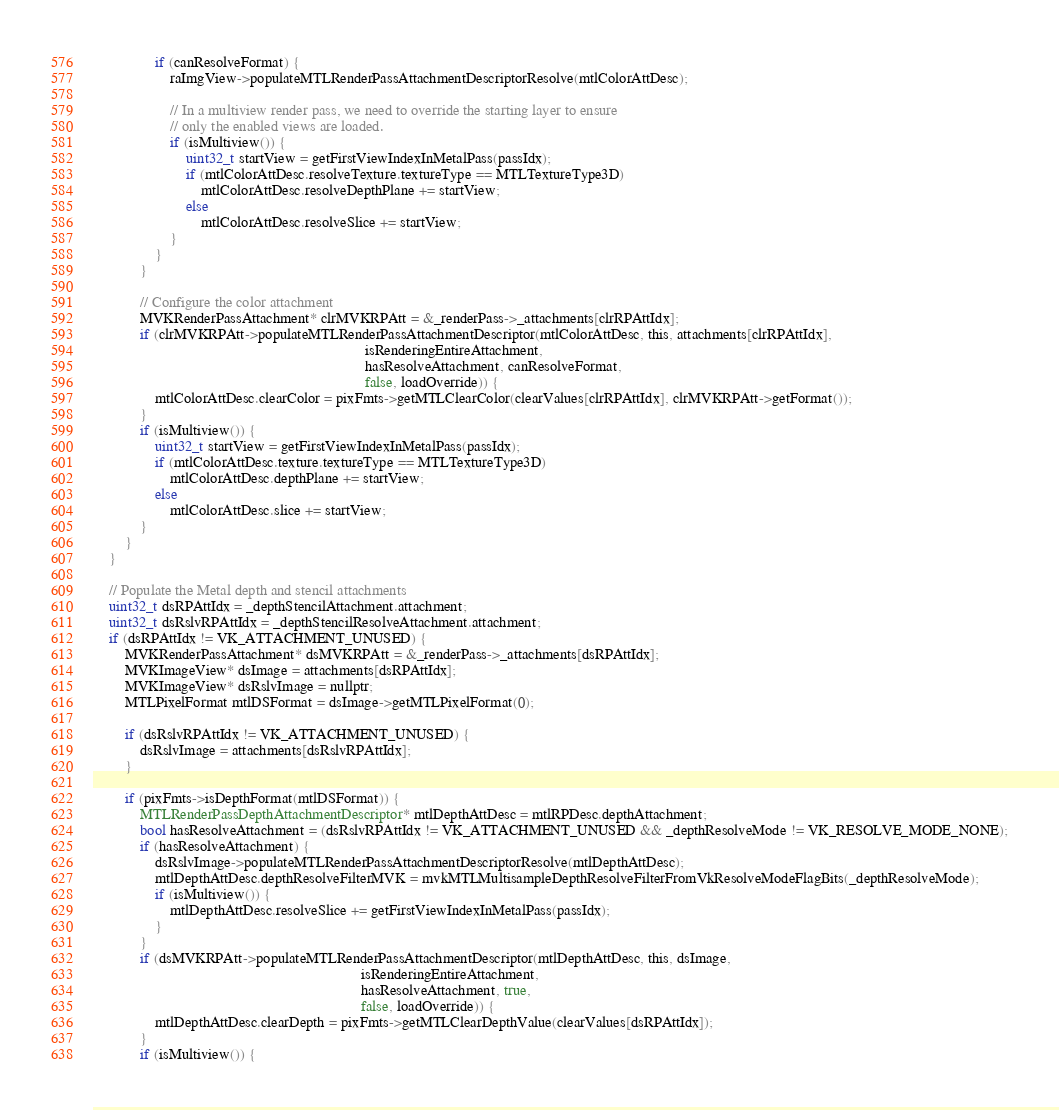<code> <loc_0><loc_0><loc_500><loc_500><_ObjectiveC_>				if (canResolveFormat) {
					raImgView->populateMTLRenderPassAttachmentDescriptorResolve(mtlColorAttDesc);

					// In a multiview render pass, we need to override the starting layer to ensure
					// only the enabled views are loaded.
					if (isMultiview()) {
						uint32_t startView = getFirstViewIndexInMetalPass(passIdx);
						if (mtlColorAttDesc.resolveTexture.textureType == MTLTextureType3D)
							mtlColorAttDesc.resolveDepthPlane += startView;
						else
							mtlColorAttDesc.resolveSlice += startView;
					}
				}
			}

            // Configure the color attachment
            MVKRenderPassAttachment* clrMVKRPAtt = &_renderPass->_attachments[clrRPAttIdx];
			if (clrMVKRPAtt->populateMTLRenderPassAttachmentDescriptor(mtlColorAttDesc, this, attachments[clrRPAttIdx],
                                                                       isRenderingEntireAttachment,
                                                                       hasResolveAttachment, canResolveFormat,
																	   false, loadOverride)) {
				mtlColorAttDesc.clearColor = pixFmts->getMTLClearColor(clearValues[clrRPAttIdx], clrMVKRPAtt->getFormat());
			}
			if (isMultiview()) {
				uint32_t startView = getFirstViewIndexInMetalPass(passIdx);
				if (mtlColorAttDesc.texture.textureType == MTLTextureType3D)
					mtlColorAttDesc.depthPlane += startView;
				else
					mtlColorAttDesc.slice += startView;
			}
		}
	}

	// Populate the Metal depth and stencil attachments
	uint32_t dsRPAttIdx = _depthStencilAttachment.attachment;
	uint32_t dsRslvRPAttIdx = _depthStencilResolveAttachment.attachment;
	if (dsRPAttIdx != VK_ATTACHMENT_UNUSED) {
		MVKRenderPassAttachment* dsMVKRPAtt = &_renderPass->_attachments[dsRPAttIdx];
		MVKImageView* dsImage = attachments[dsRPAttIdx];
		MVKImageView* dsRslvImage = nullptr;
		MTLPixelFormat mtlDSFormat = dsImage->getMTLPixelFormat(0);

		if (dsRslvRPAttIdx != VK_ATTACHMENT_UNUSED) {
			dsRslvImage = attachments[dsRslvRPAttIdx];
		}

		if (pixFmts->isDepthFormat(mtlDSFormat)) {
			MTLRenderPassDepthAttachmentDescriptor* mtlDepthAttDesc = mtlRPDesc.depthAttachment;
			bool hasResolveAttachment = (dsRslvRPAttIdx != VK_ATTACHMENT_UNUSED && _depthResolveMode != VK_RESOLVE_MODE_NONE);
			if (hasResolveAttachment) {
				dsRslvImage->populateMTLRenderPassAttachmentDescriptorResolve(mtlDepthAttDesc);
				mtlDepthAttDesc.depthResolveFilterMVK = mvkMTLMultisampleDepthResolveFilterFromVkResolveModeFlagBits(_depthResolveMode);
				if (isMultiview()) {
					mtlDepthAttDesc.resolveSlice += getFirstViewIndexInMetalPass(passIdx);
				}
			}
			if (dsMVKRPAtt->populateMTLRenderPassAttachmentDescriptor(mtlDepthAttDesc, this, dsImage,
                                                                      isRenderingEntireAttachment,
                                                                      hasResolveAttachment, true,
																	  false, loadOverride)) {
                mtlDepthAttDesc.clearDepth = pixFmts->getMTLClearDepthValue(clearValues[dsRPAttIdx]);
			}
			if (isMultiview()) {</code> 